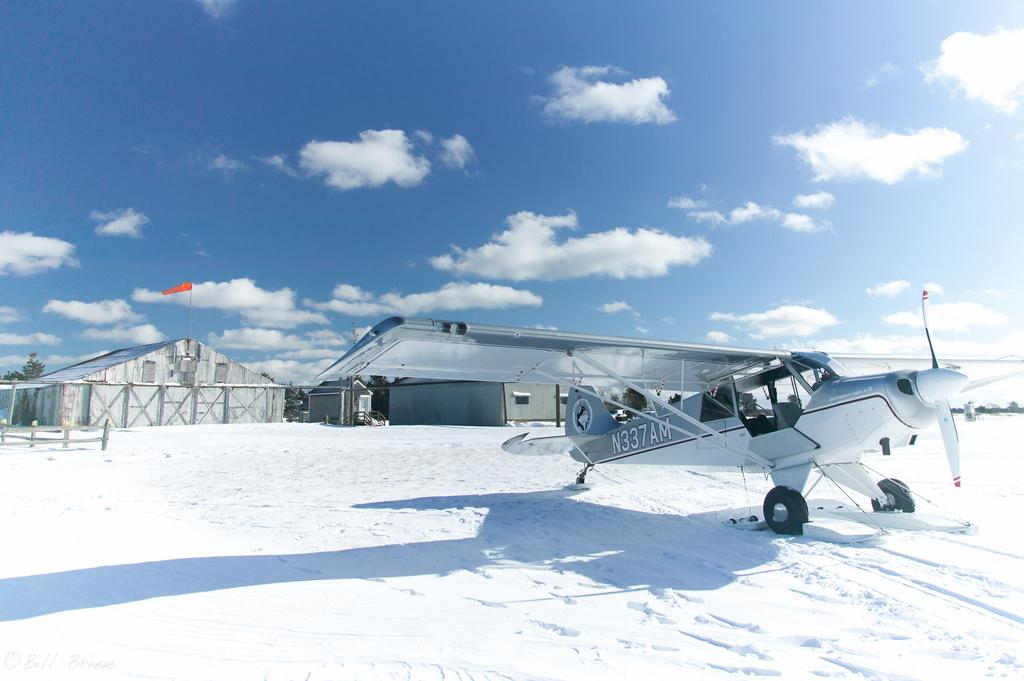<image>
Present a compact description of the photo's key features. A small N337AM plane waits at a snowy airport. 